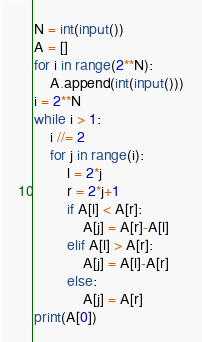Convert code to text. <code><loc_0><loc_0><loc_500><loc_500><_Python_>N = int(input())
A = []
for i in range(2**N):
    A.append(int(input()))
i = 2**N
while i > 1:
    i //= 2
    for j in range(i):
        l = 2*j
        r = 2*j+1
        if A[l] < A[r]:
            A[j] = A[r]-A[l]
        elif A[l] > A[r]:
            A[j] = A[l]-A[r]
        else:
            A[j] = A[r]
print(A[0])</code> 